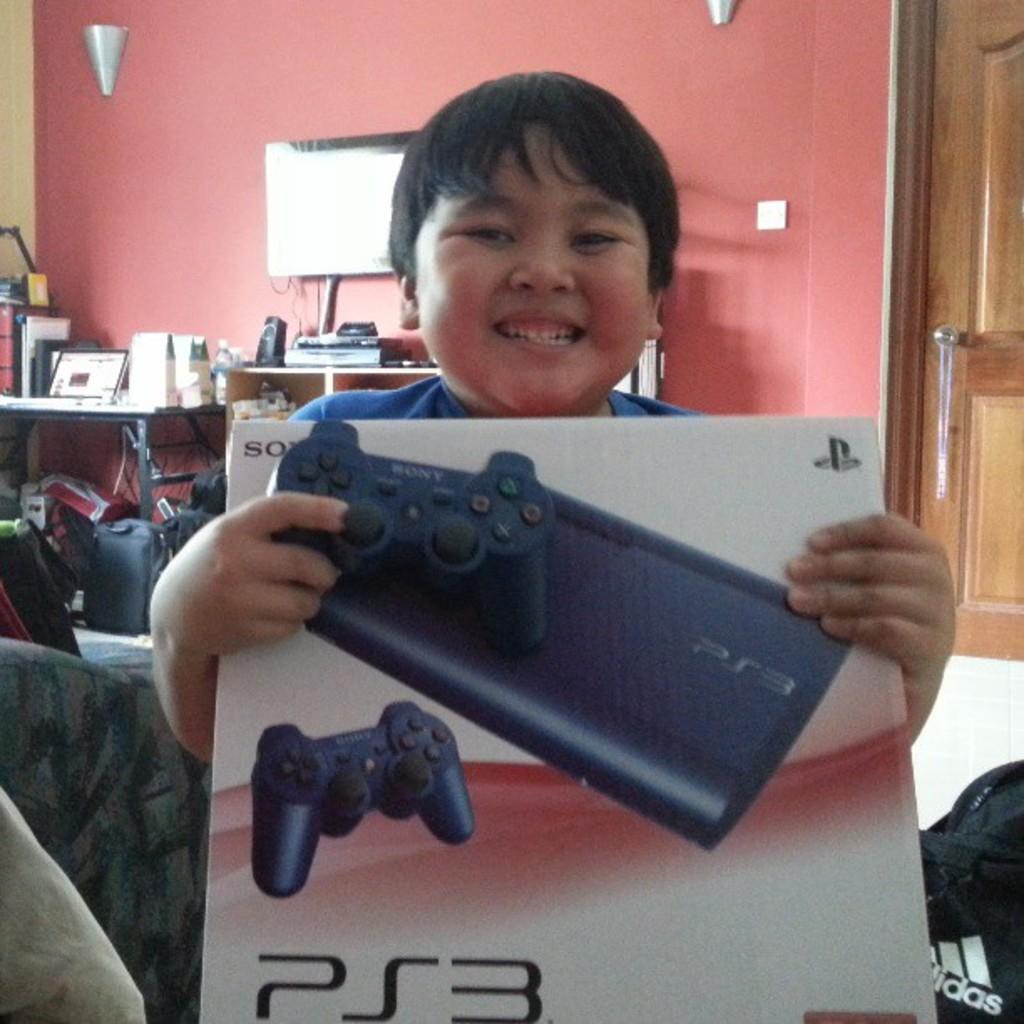How would you summarize this image in a sentence or two? This picture is clicked inside. In the foreground there is a kid holding a joystick and a box. In the background we can see the bags placed on the ground and there is a table and a cabinet on the top of them some items are placed. In the background we can see the wooden door, wall, television and some other items. 